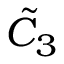<formula> <loc_0><loc_0><loc_500><loc_500>{ \tilde { C } } _ { 3 }</formula> 